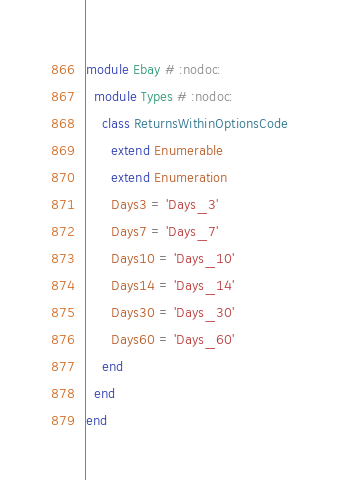Convert code to text. <code><loc_0><loc_0><loc_500><loc_500><_Ruby_>module Ebay # :nodoc:
  module Types # :nodoc:
    class ReturnsWithinOptionsCode
      extend Enumerable
      extend Enumeration
      Days3 = 'Days_3'
      Days7 = 'Days_7'
      Days10 = 'Days_10'
      Days14 = 'Days_14'
      Days30 = 'Days_30'
      Days60 = 'Days_60'
    end
  end
end

</code> 